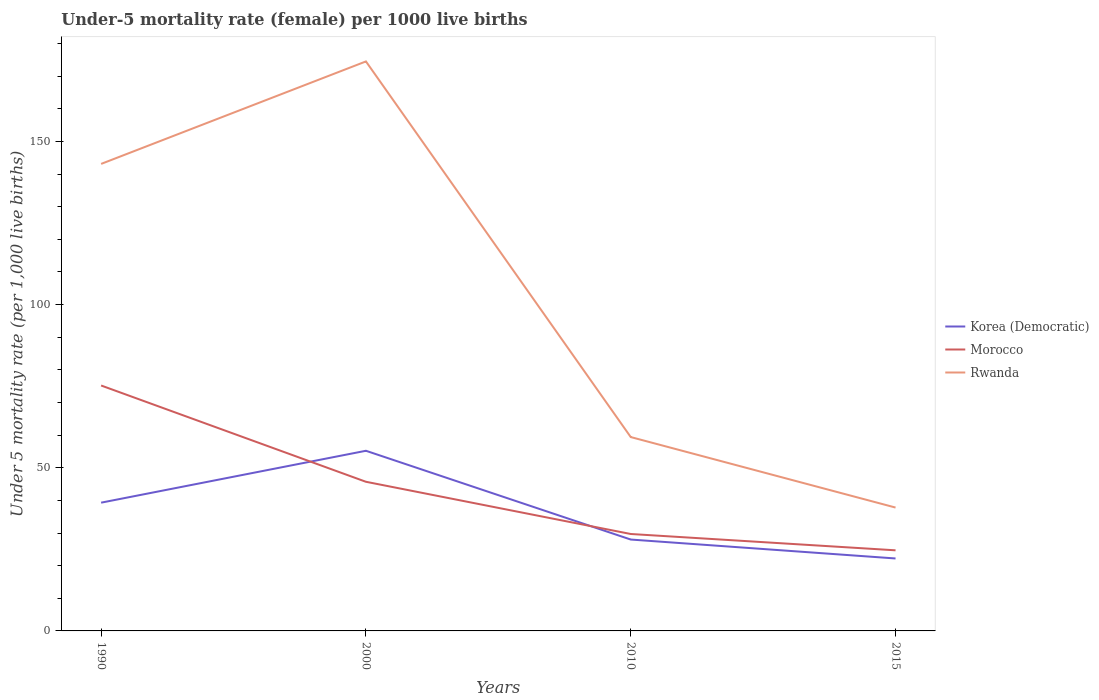Across all years, what is the maximum under-five mortality rate in Korea (Democratic)?
Provide a short and direct response. 22.2. In which year was the under-five mortality rate in Morocco maximum?
Provide a succinct answer. 2015. What is the total under-five mortality rate in Korea (Democratic) in the graph?
Provide a succinct answer. -15.9. What is the difference between the highest and the second highest under-five mortality rate in Morocco?
Give a very brief answer. 50.5. Is the under-five mortality rate in Morocco strictly greater than the under-five mortality rate in Korea (Democratic) over the years?
Make the answer very short. No. How many lines are there?
Your answer should be very brief. 3. How many years are there in the graph?
Provide a succinct answer. 4. Are the values on the major ticks of Y-axis written in scientific E-notation?
Provide a succinct answer. No. Does the graph contain grids?
Your answer should be compact. No. Where does the legend appear in the graph?
Offer a very short reply. Center right. How are the legend labels stacked?
Ensure brevity in your answer.  Vertical. What is the title of the graph?
Your answer should be compact. Under-5 mortality rate (female) per 1000 live births. Does "Zambia" appear as one of the legend labels in the graph?
Your answer should be very brief. No. What is the label or title of the Y-axis?
Your answer should be compact. Under 5 mortality rate (per 1,0 live births). What is the Under 5 mortality rate (per 1,000 live births) of Korea (Democratic) in 1990?
Your answer should be compact. 39.3. What is the Under 5 mortality rate (per 1,000 live births) in Morocco in 1990?
Your response must be concise. 75.2. What is the Under 5 mortality rate (per 1,000 live births) in Rwanda in 1990?
Offer a terse response. 143.1. What is the Under 5 mortality rate (per 1,000 live births) of Korea (Democratic) in 2000?
Give a very brief answer. 55.2. What is the Under 5 mortality rate (per 1,000 live births) in Morocco in 2000?
Give a very brief answer. 45.7. What is the Under 5 mortality rate (per 1,000 live births) of Rwanda in 2000?
Offer a very short reply. 174.5. What is the Under 5 mortality rate (per 1,000 live births) of Morocco in 2010?
Your response must be concise. 29.7. What is the Under 5 mortality rate (per 1,000 live births) of Rwanda in 2010?
Offer a terse response. 59.4. What is the Under 5 mortality rate (per 1,000 live births) in Korea (Democratic) in 2015?
Give a very brief answer. 22.2. What is the Under 5 mortality rate (per 1,000 live births) in Morocco in 2015?
Your answer should be compact. 24.7. What is the Under 5 mortality rate (per 1,000 live births) in Rwanda in 2015?
Keep it short and to the point. 37.8. Across all years, what is the maximum Under 5 mortality rate (per 1,000 live births) in Korea (Democratic)?
Your answer should be compact. 55.2. Across all years, what is the maximum Under 5 mortality rate (per 1,000 live births) of Morocco?
Ensure brevity in your answer.  75.2. Across all years, what is the maximum Under 5 mortality rate (per 1,000 live births) of Rwanda?
Make the answer very short. 174.5. Across all years, what is the minimum Under 5 mortality rate (per 1,000 live births) in Korea (Democratic)?
Provide a short and direct response. 22.2. Across all years, what is the minimum Under 5 mortality rate (per 1,000 live births) of Morocco?
Give a very brief answer. 24.7. Across all years, what is the minimum Under 5 mortality rate (per 1,000 live births) of Rwanda?
Offer a very short reply. 37.8. What is the total Under 5 mortality rate (per 1,000 live births) of Korea (Democratic) in the graph?
Provide a short and direct response. 144.7. What is the total Under 5 mortality rate (per 1,000 live births) in Morocco in the graph?
Your answer should be compact. 175.3. What is the total Under 5 mortality rate (per 1,000 live births) of Rwanda in the graph?
Provide a short and direct response. 414.8. What is the difference between the Under 5 mortality rate (per 1,000 live births) of Korea (Democratic) in 1990 and that in 2000?
Your answer should be very brief. -15.9. What is the difference between the Under 5 mortality rate (per 1,000 live births) in Morocco in 1990 and that in 2000?
Offer a terse response. 29.5. What is the difference between the Under 5 mortality rate (per 1,000 live births) of Rwanda in 1990 and that in 2000?
Provide a short and direct response. -31.4. What is the difference between the Under 5 mortality rate (per 1,000 live births) in Korea (Democratic) in 1990 and that in 2010?
Your answer should be compact. 11.3. What is the difference between the Under 5 mortality rate (per 1,000 live births) of Morocco in 1990 and that in 2010?
Your response must be concise. 45.5. What is the difference between the Under 5 mortality rate (per 1,000 live births) of Rwanda in 1990 and that in 2010?
Your answer should be very brief. 83.7. What is the difference between the Under 5 mortality rate (per 1,000 live births) of Morocco in 1990 and that in 2015?
Give a very brief answer. 50.5. What is the difference between the Under 5 mortality rate (per 1,000 live births) of Rwanda in 1990 and that in 2015?
Make the answer very short. 105.3. What is the difference between the Under 5 mortality rate (per 1,000 live births) in Korea (Democratic) in 2000 and that in 2010?
Your answer should be compact. 27.2. What is the difference between the Under 5 mortality rate (per 1,000 live births) in Morocco in 2000 and that in 2010?
Your response must be concise. 16. What is the difference between the Under 5 mortality rate (per 1,000 live births) of Rwanda in 2000 and that in 2010?
Offer a terse response. 115.1. What is the difference between the Under 5 mortality rate (per 1,000 live births) in Morocco in 2000 and that in 2015?
Offer a terse response. 21. What is the difference between the Under 5 mortality rate (per 1,000 live births) in Rwanda in 2000 and that in 2015?
Your answer should be very brief. 136.7. What is the difference between the Under 5 mortality rate (per 1,000 live births) of Morocco in 2010 and that in 2015?
Your response must be concise. 5. What is the difference between the Under 5 mortality rate (per 1,000 live births) in Rwanda in 2010 and that in 2015?
Offer a very short reply. 21.6. What is the difference between the Under 5 mortality rate (per 1,000 live births) in Korea (Democratic) in 1990 and the Under 5 mortality rate (per 1,000 live births) in Rwanda in 2000?
Your answer should be very brief. -135.2. What is the difference between the Under 5 mortality rate (per 1,000 live births) of Morocco in 1990 and the Under 5 mortality rate (per 1,000 live births) of Rwanda in 2000?
Make the answer very short. -99.3. What is the difference between the Under 5 mortality rate (per 1,000 live births) of Korea (Democratic) in 1990 and the Under 5 mortality rate (per 1,000 live births) of Rwanda in 2010?
Ensure brevity in your answer.  -20.1. What is the difference between the Under 5 mortality rate (per 1,000 live births) of Morocco in 1990 and the Under 5 mortality rate (per 1,000 live births) of Rwanda in 2010?
Your answer should be compact. 15.8. What is the difference between the Under 5 mortality rate (per 1,000 live births) in Korea (Democratic) in 1990 and the Under 5 mortality rate (per 1,000 live births) in Morocco in 2015?
Your answer should be compact. 14.6. What is the difference between the Under 5 mortality rate (per 1,000 live births) of Morocco in 1990 and the Under 5 mortality rate (per 1,000 live births) of Rwanda in 2015?
Keep it short and to the point. 37.4. What is the difference between the Under 5 mortality rate (per 1,000 live births) of Korea (Democratic) in 2000 and the Under 5 mortality rate (per 1,000 live births) of Morocco in 2010?
Your answer should be very brief. 25.5. What is the difference between the Under 5 mortality rate (per 1,000 live births) of Korea (Democratic) in 2000 and the Under 5 mortality rate (per 1,000 live births) of Rwanda in 2010?
Your answer should be very brief. -4.2. What is the difference between the Under 5 mortality rate (per 1,000 live births) of Morocco in 2000 and the Under 5 mortality rate (per 1,000 live births) of Rwanda in 2010?
Keep it short and to the point. -13.7. What is the difference between the Under 5 mortality rate (per 1,000 live births) in Korea (Democratic) in 2000 and the Under 5 mortality rate (per 1,000 live births) in Morocco in 2015?
Your answer should be compact. 30.5. What is the difference between the Under 5 mortality rate (per 1,000 live births) of Korea (Democratic) in 2000 and the Under 5 mortality rate (per 1,000 live births) of Rwanda in 2015?
Provide a short and direct response. 17.4. What is the difference between the Under 5 mortality rate (per 1,000 live births) in Morocco in 2000 and the Under 5 mortality rate (per 1,000 live births) in Rwanda in 2015?
Ensure brevity in your answer.  7.9. What is the difference between the Under 5 mortality rate (per 1,000 live births) of Korea (Democratic) in 2010 and the Under 5 mortality rate (per 1,000 live births) of Rwanda in 2015?
Offer a very short reply. -9.8. What is the difference between the Under 5 mortality rate (per 1,000 live births) of Morocco in 2010 and the Under 5 mortality rate (per 1,000 live births) of Rwanda in 2015?
Make the answer very short. -8.1. What is the average Under 5 mortality rate (per 1,000 live births) of Korea (Democratic) per year?
Keep it short and to the point. 36.17. What is the average Under 5 mortality rate (per 1,000 live births) of Morocco per year?
Your answer should be very brief. 43.83. What is the average Under 5 mortality rate (per 1,000 live births) in Rwanda per year?
Provide a short and direct response. 103.7. In the year 1990, what is the difference between the Under 5 mortality rate (per 1,000 live births) of Korea (Democratic) and Under 5 mortality rate (per 1,000 live births) of Morocco?
Give a very brief answer. -35.9. In the year 1990, what is the difference between the Under 5 mortality rate (per 1,000 live births) of Korea (Democratic) and Under 5 mortality rate (per 1,000 live births) of Rwanda?
Your answer should be very brief. -103.8. In the year 1990, what is the difference between the Under 5 mortality rate (per 1,000 live births) in Morocco and Under 5 mortality rate (per 1,000 live births) in Rwanda?
Ensure brevity in your answer.  -67.9. In the year 2000, what is the difference between the Under 5 mortality rate (per 1,000 live births) in Korea (Democratic) and Under 5 mortality rate (per 1,000 live births) in Morocco?
Give a very brief answer. 9.5. In the year 2000, what is the difference between the Under 5 mortality rate (per 1,000 live births) in Korea (Democratic) and Under 5 mortality rate (per 1,000 live births) in Rwanda?
Offer a terse response. -119.3. In the year 2000, what is the difference between the Under 5 mortality rate (per 1,000 live births) of Morocco and Under 5 mortality rate (per 1,000 live births) of Rwanda?
Your answer should be compact. -128.8. In the year 2010, what is the difference between the Under 5 mortality rate (per 1,000 live births) of Korea (Democratic) and Under 5 mortality rate (per 1,000 live births) of Rwanda?
Ensure brevity in your answer.  -31.4. In the year 2010, what is the difference between the Under 5 mortality rate (per 1,000 live births) in Morocco and Under 5 mortality rate (per 1,000 live births) in Rwanda?
Give a very brief answer. -29.7. In the year 2015, what is the difference between the Under 5 mortality rate (per 1,000 live births) in Korea (Democratic) and Under 5 mortality rate (per 1,000 live births) in Morocco?
Keep it short and to the point. -2.5. In the year 2015, what is the difference between the Under 5 mortality rate (per 1,000 live births) of Korea (Democratic) and Under 5 mortality rate (per 1,000 live births) of Rwanda?
Provide a succinct answer. -15.6. In the year 2015, what is the difference between the Under 5 mortality rate (per 1,000 live births) in Morocco and Under 5 mortality rate (per 1,000 live births) in Rwanda?
Your answer should be very brief. -13.1. What is the ratio of the Under 5 mortality rate (per 1,000 live births) of Korea (Democratic) in 1990 to that in 2000?
Keep it short and to the point. 0.71. What is the ratio of the Under 5 mortality rate (per 1,000 live births) in Morocco in 1990 to that in 2000?
Offer a terse response. 1.65. What is the ratio of the Under 5 mortality rate (per 1,000 live births) in Rwanda in 1990 to that in 2000?
Provide a short and direct response. 0.82. What is the ratio of the Under 5 mortality rate (per 1,000 live births) in Korea (Democratic) in 1990 to that in 2010?
Offer a very short reply. 1.4. What is the ratio of the Under 5 mortality rate (per 1,000 live births) of Morocco in 1990 to that in 2010?
Ensure brevity in your answer.  2.53. What is the ratio of the Under 5 mortality rate (per 1,000 live births) in Rwanda in 1990 to that in 2010?
Give a very brief answer. 2.41. What is the ratio of the Under 5 mortality rate (per 1,000 live births) of Korea (Democratic) in 1990 to that in 2015?
Ensure brevity in your answer.  1.77. What is the ratio of the Under 5 mortality rate (per 1,000 live births) in Morocco in 1990 to that in 2015?
Provide a short and direct response. 3.04. What is the ratio of the Under 5 mortality rate (per 1,000 live births) in Rwanda in 1990 to that in 2015?
Make the answer very short. 3.79. What is the ratio of the Under 5 mortality rate (per 1,000 live births) in Korea (Democratic) in 2000 to that in 2010?
Provide a succinct answer. 1.97. What is the ratio of the Under 5 mortality rate (per 1,000 live births) of Morocco in 2000 to that in 2010?
Your response must be concise. 1.54. What is the ratio of the Under 5 mortality rate (per 1,000 live births) of Rwanda in 2000 to that in 2010?
Give a very brief answer. 2.94. What is the ratio of the Under 5 mortality rate (per 1,000 live births) of Korea (Democratic) in 2000 to that in 2015?
Your answer should be compact. 2.49. What is the ratio of the Under 5 mortality rate (per 1,000 live births) in Morocco in 2000 to that in 2015?
Your answer should be compact. 1.85. What is the ratio of the Under 5 mortality rate (per 1,000 live births) in Rwanda in 2000 to that in 2015?
Offer a very short reply. 4.62. What is the ratio of the Under 5 mortality rate (per 1,000 live births) in Korea (Democratic) in 2010 to that in 2015?
Keep it short and to the point. 1.26. What is the ratio of the Under 5 mortality rate (per 1,000 live births) in Morocco in 2010 to that in 2015?
Ensure brevity in your answer.  1.2. What is the ratio of the Under 5 mortality rate (per 1,000 live births) of Rwanda in 2010 to that in 2015?
Offer a very short reply. 1.57. What is the difference between the highest and the second highest Under 5 mortality rate (per 1,000 live births) in Morocco?
Offer a terse response. 29.5. What is the difference between the highest and the second highest Under 5 mortality rate (per 1,000 live births) in Rwanda?
Provide a succinct answer. 31.4. What is the difference between the highest and the lowest Under 5 mortality rate (per 1,000 live births) in Korea (Democratic)?
Your response must be concise. 33. What is the difference between the highest and the lowest Under 5 mortality rate (per 1,000 live births) of Morocco?
Ensure brevity in your answer.  50.5. What is the difference between the highest and the lowest Under 5 mortality rate (per 1,000 live births) of Rwanda?
Offer a terse response. 136.7. 